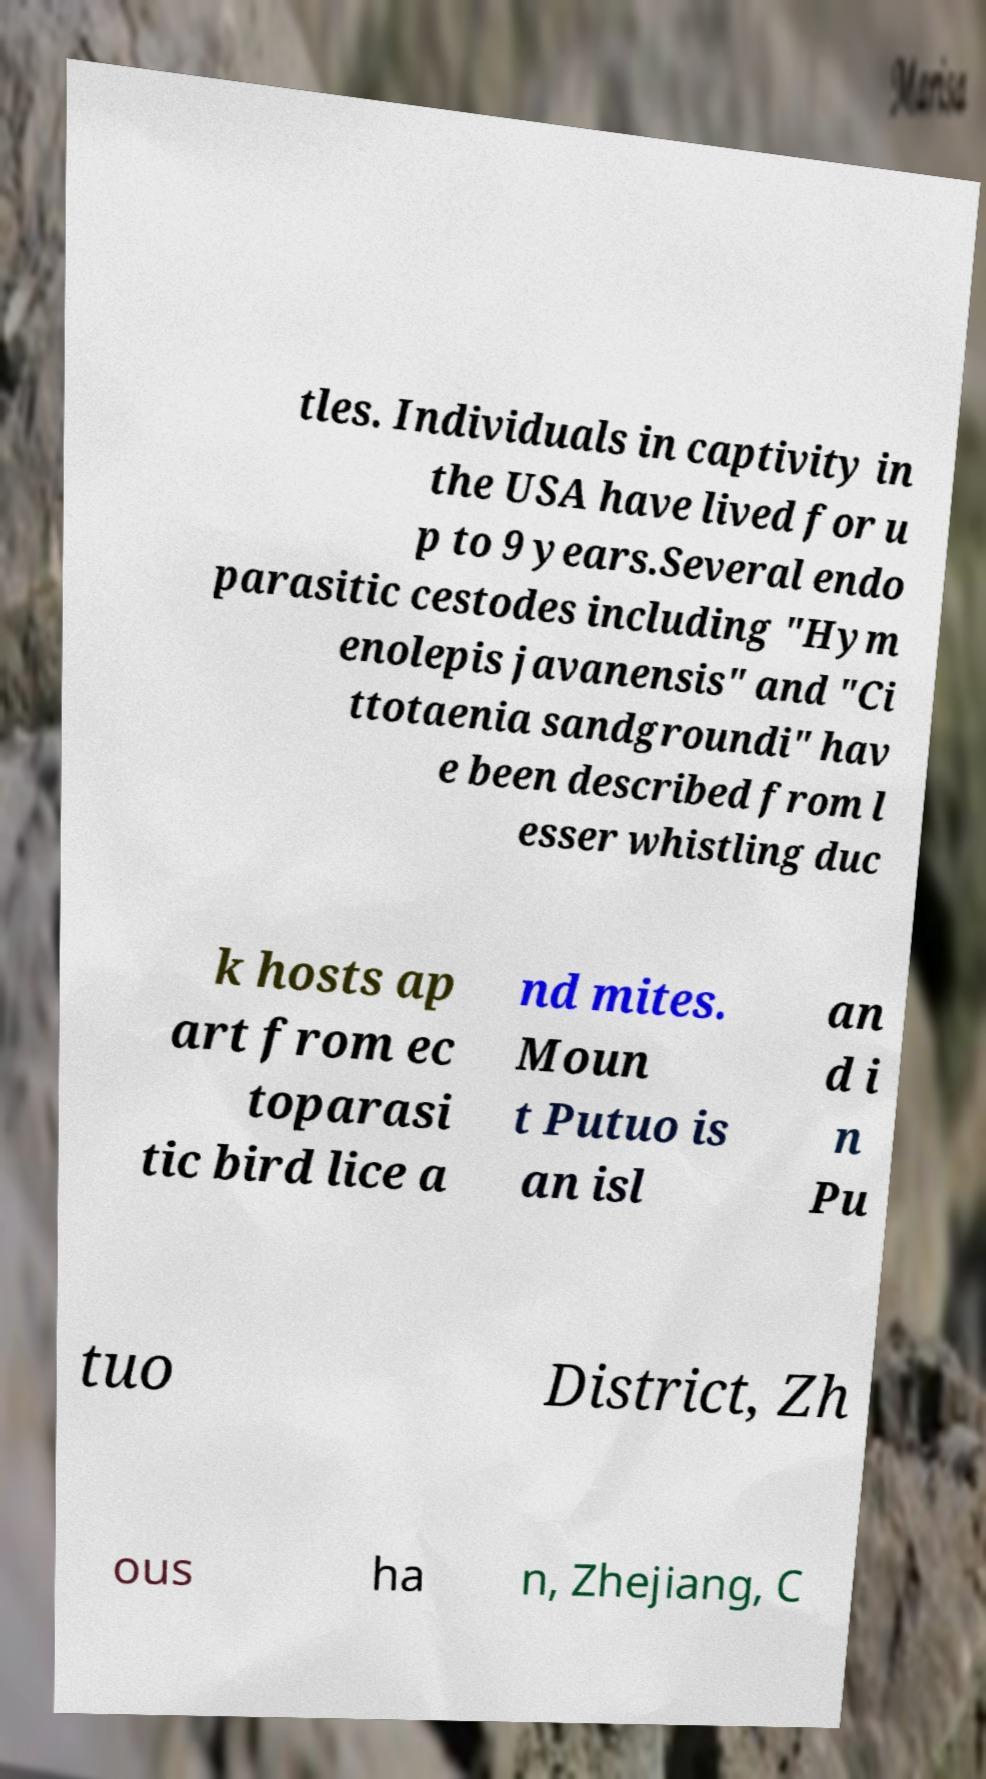Please read and relay the text visible in this image. What does it say? tles. Individuals in captivity in the USA have lived for u p to 9 years.Several endo parasitic cestodes including "Hym enolepis javanensis" and "Ci ttotaenia sandgroundi" hav e been described from l esser whistling duc k hosts ap art from ec toparasi tic bird lice a nd mites. Moun t Putuo is an isl an d i n Pu tuo District, Zh ous ha n, Zhejiang, C 